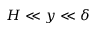<formula> <loc_0><loc_0><loc_500><loc_500>H \ll y \ll \delta</formula> 